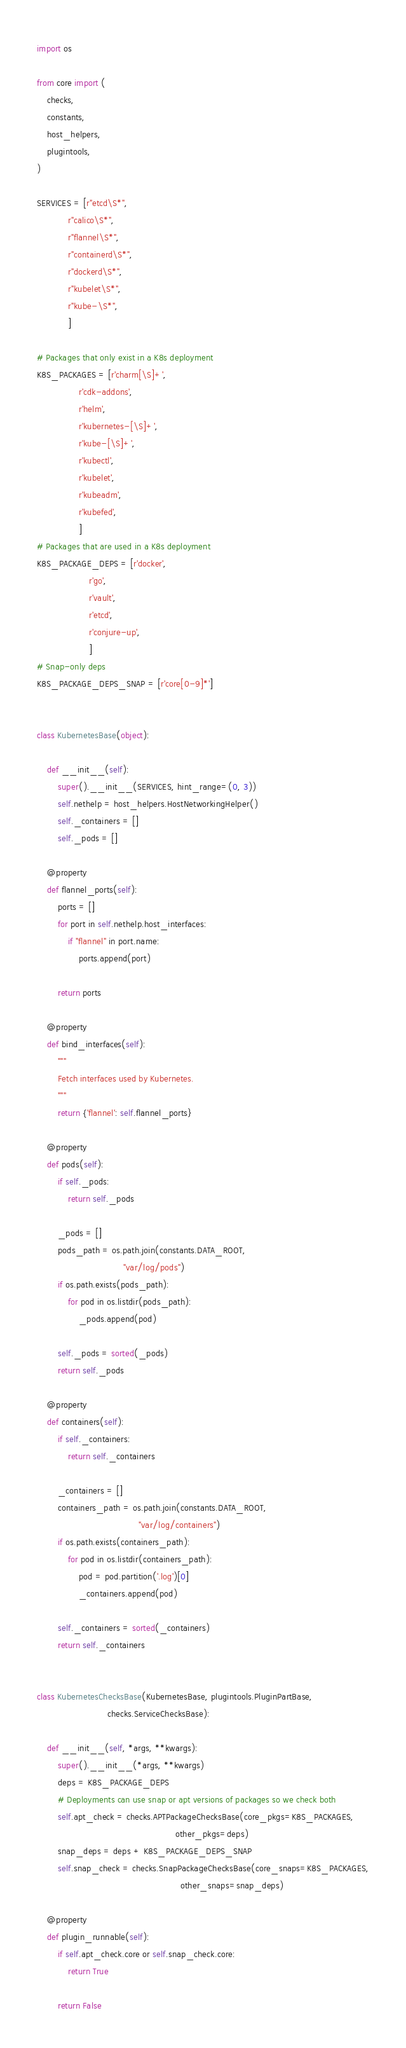<code> <loc_0><loc_0><loc_500><loc_500><_Python_>import os

from core import (
    checks,
    constants,
    host_helpers,
    plugintools,
)

SERVICES = [r"etcd\S*",
            r"calico\S*",
            r"flannel\S*",
            r"containerd\S*",
            r"dockerd\S*",
            r"kubelet\S*",
            r"kube-\S*",
            ]

# Packages that only exist in a K8s deployment
K8S_PACKAGES = [r'charm[\S]+',
                r'cdk-addons',
                r'helm',
                r'kubernetes-[\S]+',
                r'kube-[\S]+',
                r'kubectl',
                r'kubelet',
                r'kubeadm',
                r'kubefed',
                ]
# Packages that are used in a K8s deployment
K8S_PACKAGE_DEPS = [r'docker',
                    r'go',
                    r'vault',
                    r'etcd',
                    r'conjure-up',
                    ]
# Snap-only deps
K8S_PACKAGE_DEPS_SNAP = [r'core[0-9]*']


class KubernetesBase(object):

    def __init__(self):
        super().__init__(SERVICES, hint_range=(0, 3))
        self.nethelp = host_helpers.HostNetworkingHelper()
        self._containers = []
        self._pods = []

    @property
    def flannel_ports(self):
        ports = []
        for port in self.nethelp.host_interfaces:
            if "flannel" in port.name:
                ports.append(port)

        return ports

    @property
    def bind_interfaces(self):
        """
        Fetch interfaces used by Kubernetes.
        """
        return {'flannel': self.flannel_ports}

    @property
    def pods(self):
        if self._pods:
            return self._pods

        _pods = []
        pods_path = os.path.join(constants.DATA_ROOT,
                                 "var/log/pods")
        if os.path.exists(pods_path):
            for pod in os.listdir(pods_path):
                _pods.append(pod)

        self._pods = sorted(_pods)
        return self._pods

    @property
    def containers(self):
        if self._containers:
            return self._containers

        _containers = []
        containers_path = os.path.join(constants.DATA_ROOT,
                                       "var/log/containers")
        if os.path.exists(containers_path):
            for pod in os.listdir(containers_path):
                pod = pod.partition('.log')[0]
                _containers.append(pod)

        self._containers = sorted(_containers)
        return self._containers


class KubernetesChecksBase(KubernetesBase, plugintools.PluginPartBase,
                           checks.ServiceChecksBase):

    def __init__(self, *args, **kwargs):
        super().__init__(*args, **kwargs)
        deps = K8S_PACKAGE_DEPS
        # Deployments can use snap or apt versions of packages so we check both
        self.apt_check = checks.APTPackageChecksBase(core_pkgs=K8S_PACKAGES,
                                                     other_pkgs=deps)
        snap_deps = deps + K8S_PACKAGE_DEPS_SNAP
        self.snap_check = checks.SnapPackageChecksBase(core_snaps=K8S_PACKAGES,
                                                       other_snaps=snap_deps)

    @property
    def plugin_runnable(self):
        if self.apt_check.core or self.snap_check.core:
            return True

        return False
</code> 